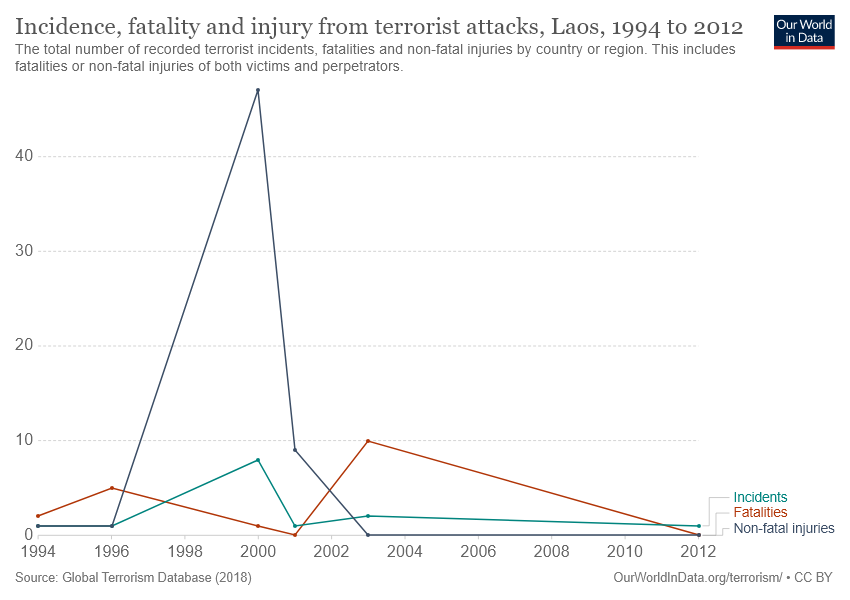Draw attention to some important aspects in this diagram. In the study, the peak value of non-fatal injuries was found to be significantly larger than the sum of the peak values of the other two items. Non-fatal injuries hold the highest historical value. 